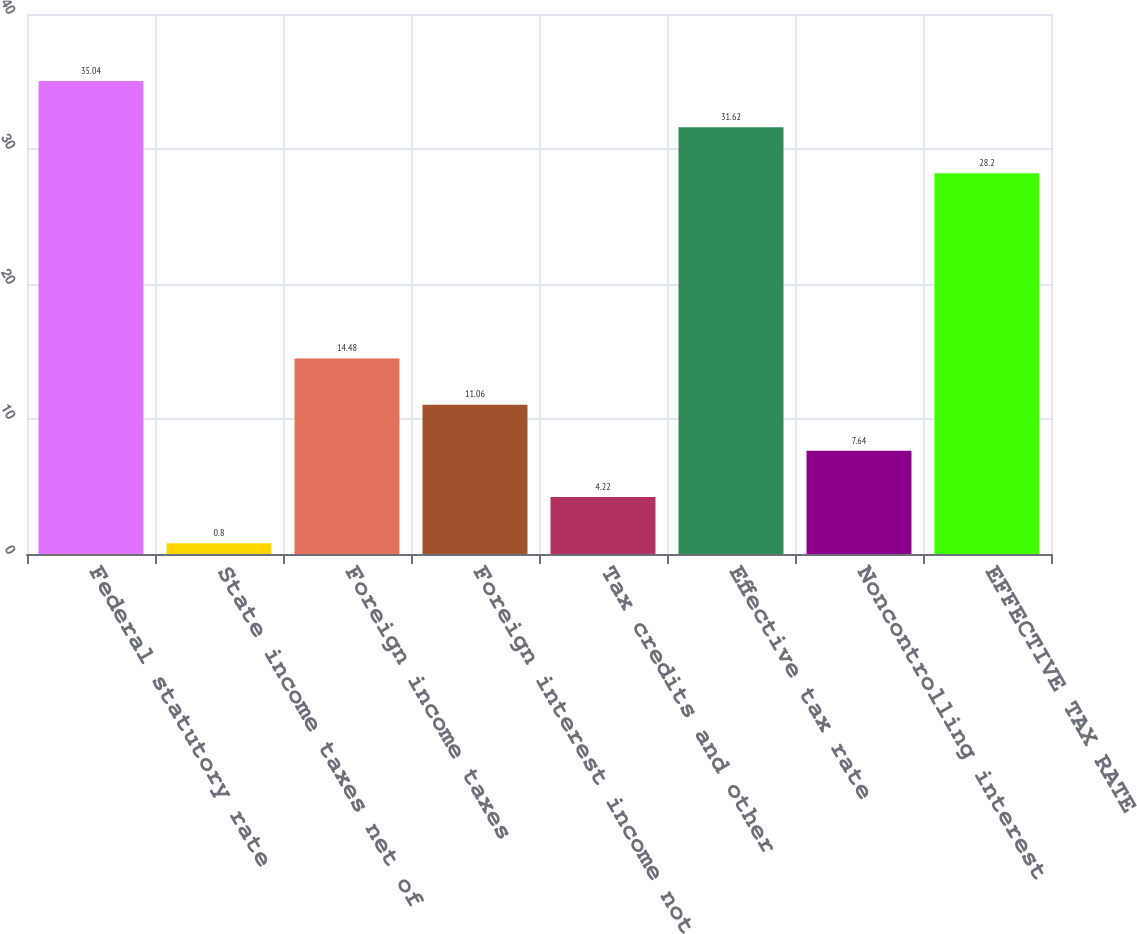<chart> <loc_0><loc_0><loc_500><loc_500><bar_chart><fcel>Federal statutory rate<fcel>State income taxes net of<fcel>Foreign income taxes<fcel>Foreign interest income not<fcel>Tax credits and other<fcel>Effective tax rate<fcel>Noncontrolling interest<fcel>EFFECTIVE TAX RATE<nl><fcel>35.04<fcel>0.8<fcel>14.48<fcel>11.06<fcel>4.22<fcel>31.62<fcel>7.64<fcel>28.2<nl></chart> 